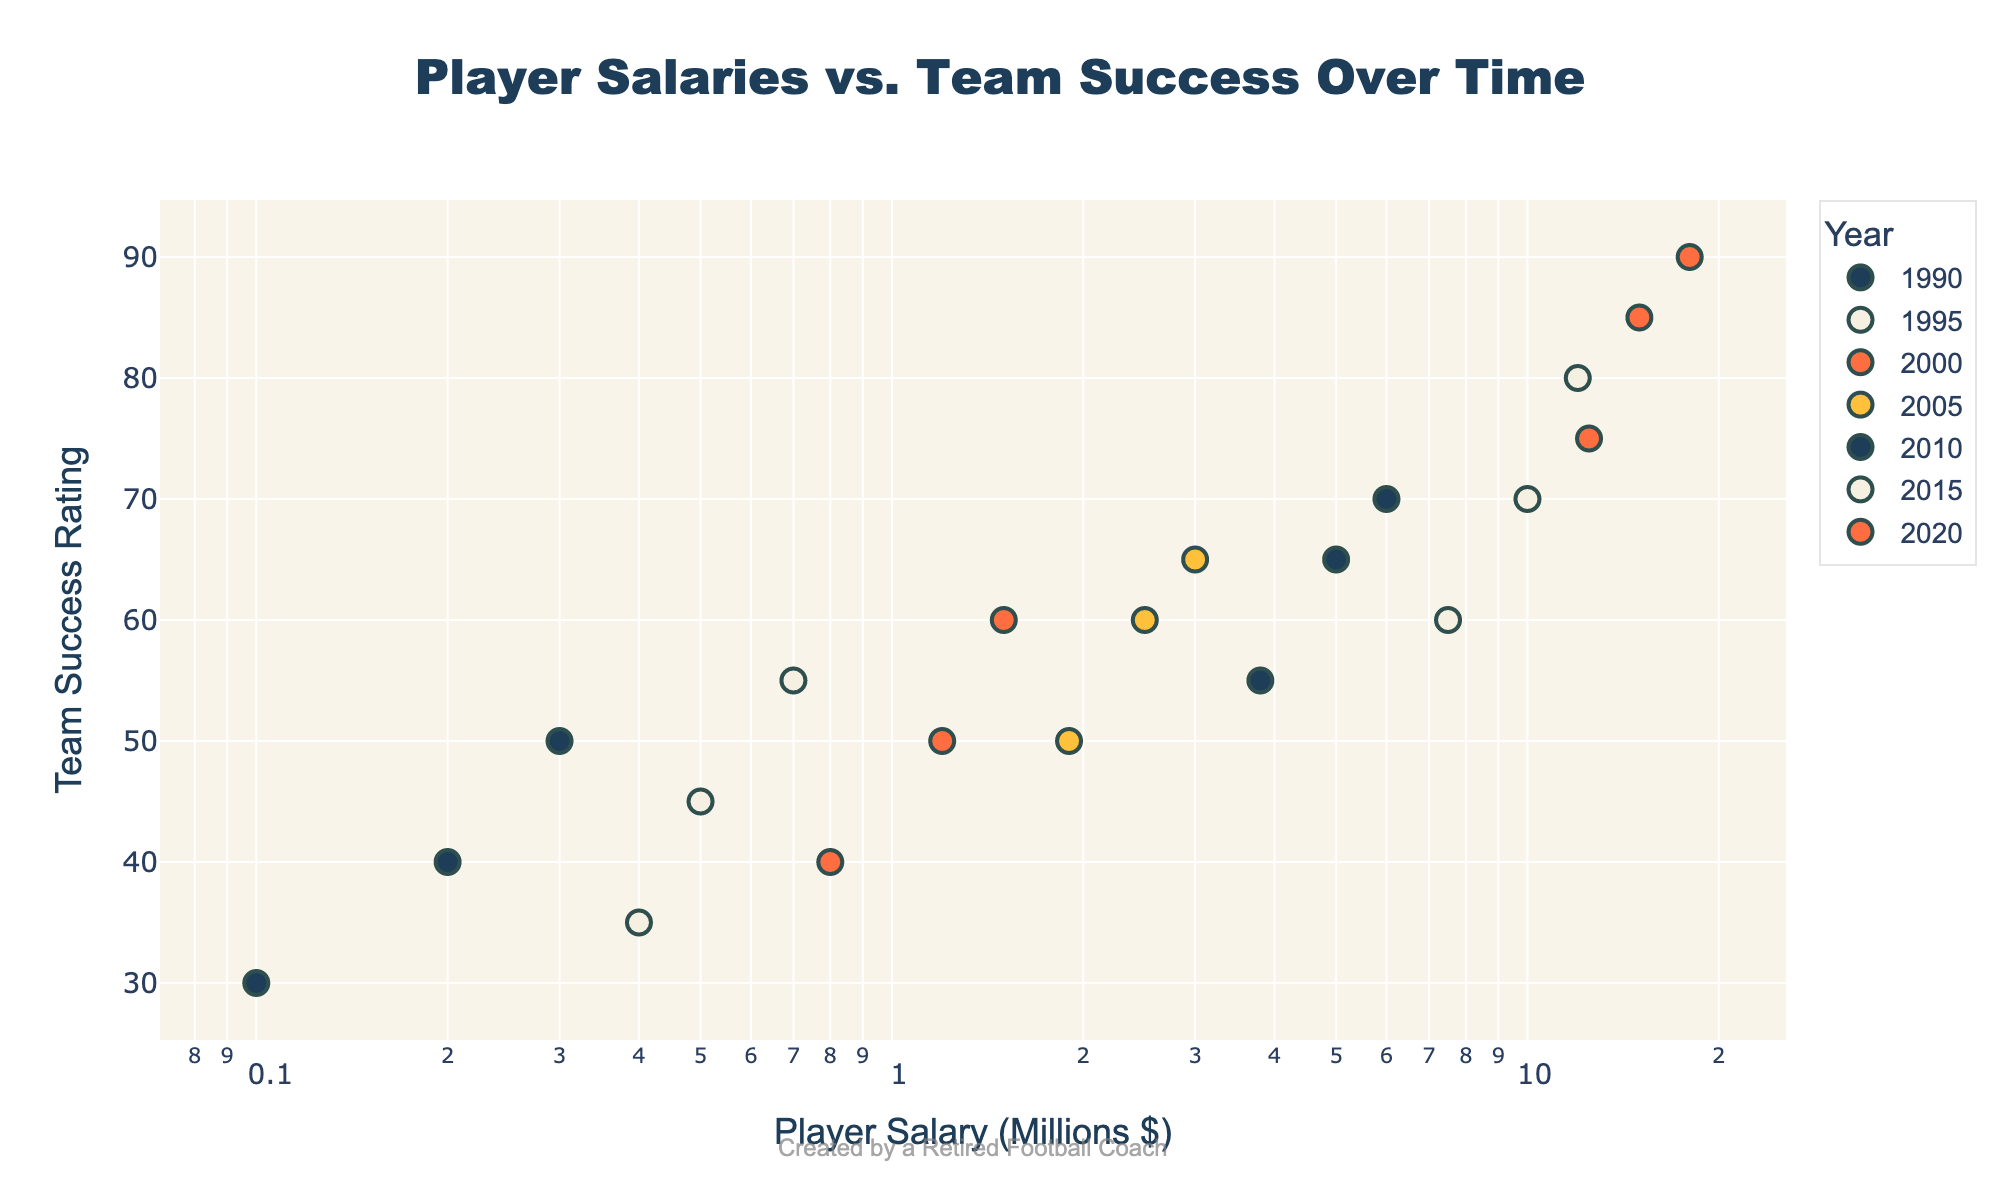what's the title of the figure? The title of the figure is prominently displayed at the top. It reads "Player Salaries vs. Team Success Over Time". Therefore, the title of the figure is "Player Salaries vs. Team Success Over Time".
Answer: Player Salaries vs. Team Success Over Time What are the axis titles in the figure? The x-axis and y-axis titles describe what is being measured. The x-axis title is "Player Salary (Millions $)" and the y-axis title is "Team Success Rating". Therefore, the axis titles are "Player Salary (Millions $)" and "Team Success Rating".
Answer: Player Salary (Millions $) and Team Success Rating How many years of data are plotted in the figure? By examining the legend, we can see distinct years labeled with different colors. There are seven different years: 1990, 1995, 2000, 2005, 2010, 2015, and 2020. Thus, there are seven years of data plotted.
Answer: Seven What is the trend in Team Success as Player Salaries increase from 1990 to 2020? Observing the scatter plot, as Player Salaries increase over the years, there is a visible upward trend in Team Success Ratings from around 30 in 1990 to around 90 in 2020. Therefore, the trend is that Team Success increases as Player Salaries increase.
Answer: Team Success increases Which year has the highest Team Success Rating at the highest salary level? By looking at the scatter plot, we identify the highest Team Success Rating at the highest Player Salary level. In this case, the year 2020, with a Player Salary of 18 million dollars and a Team Success Rating of 90, has the highest Team Success at the highest salary level.
Answer: 2020 What is the range of Player Salaries in the year 2010? Focusing on the data points from 2010, we observe Player Salaries ranging from the lowest to the highest. In 2010, the lowest Player Salary is 3.8 million dollars and the highest is 6.0 million dollars. So, the range is from 3.8 million to 6.0 million dollars.
Answer: 3.8 million to 6.0 million dollars Compare the median Team Success Rating of data points from 2000 and 2015. First, identify the Team Success Ratings for 2000: 40, 50, and 60. The median of these values is 50. For 2015, the Team Success Ratings are 60, 70, and 80. The median of these values is 70. Hence, the median Team Success for 2015 is higher than that of 2000.
Answer: 2015 has a higher median Between 1990 and 2020, do higher Player Salaries always result in better Team Success Ratings? Observing the scatter plot, generally higher Player Salaries correlate with better Team Success Ratings. However, there are some exceptions, like in the year 2015, where a lower salary (7.5 million) had a Team Success Rating of 60, while a higher salary (10 million) had a success rating of 70, indicating it is not absolute. So higher salaries do not always result in better success.
Answer: No, not always What's the average Team Success Rating for the year 2005? For the year 2005, we have Team Success Ratings as 50, 60, and 65. To find the average, sum these values: (50 + 60 + 65) = 175, then divide by 3 (number of data points): 175/3 = 58.33. So, the average Team Success Rating for 2005 is 58.33.
Answer: 58.33 